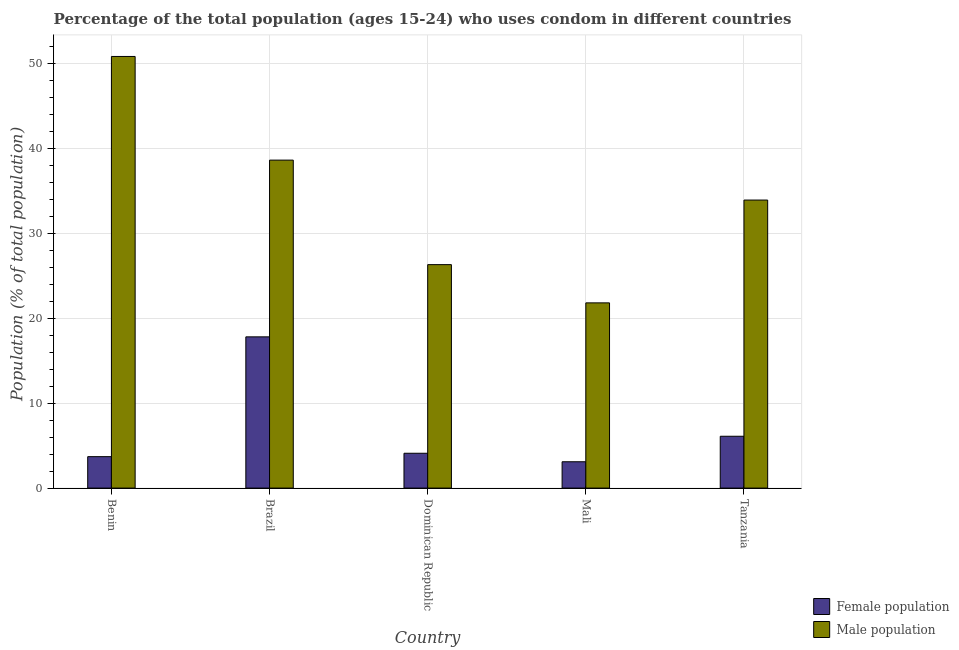How many groups of bars are there?
Make the answer very short. 5. Are the number of bars per tick equal to the number of legend labels?
Ensure brevity in your answer.  Yes. How many bars are there on the 2nd tick from the left?
Provide a short and direct response. 2. How many bars are there on the 3rd tick from the right?
Offer a very short reply. 2. What is the label of the 2nd group of bars from the left?
Provide a short and direct response. Brazil. Across all countries, what is the minimum female population?
Make the answer very short. 3.1. In which country was the female population maximum?
Your response must be concise. Brazil. In which country was the female population minimum?
Offer a terse response. Mali. What is the total male population in the graph?
Give a very brief answer. 171.4. What is the difference between the male population in Benin and that in Brazil?
Make the answer very short. 12.2. What is the difference between the male population in Brazil and the female population in Dominican Republic?
Your response must be concise. 34.5. What is the average male population per country?
Your answer should be very brief. 34.28. What is the difference between the male population and female population in Dominican Republic?
Make the answer very short. 22.2. In how many countries, is the male population greater than 20 %?
Provide a succinct answer. 5. What is the ratio of the female population in Benin to that in Mali?
Offer a very short reply. 1.19. Is the male population in Mali less than that in Tanzania?
Provide a short and direct response. Yes. Is the difference between the male population in Mali and Tanzania greater than the difference between the female population in Mali and Tanzania?
Offer a very short reply. No. What is the difference between the highest and the second highest male population?
Offer a very short reply. 12.2. What is the difference between the highest and the lowest female population?
Your answer should be very brief. 14.7. Is the sum of the female population in Mali and Tanzania greater than the maximum male population across all countries?
Provide a short and direct response. No. What does the 1st bar from the left in Brazil represents?
Offer a very short reply. Female population. What does the 1st bar from the right in Tanzania represents?
Offer a terse response. Male population. Are all the bars in the graph horizontal?
Offer a terse response. No. How many countries are there in the graph?
Offer a terse response. 5. What is the difference between two consecutive major ticks on the Y-axis?
Make the answer very short. 10. Are the values on the major ticks of Y-axis written in scientific E-notation?
Offer a terse response. No. Does the graph contain any zero values?
Ensure brevity in your answer.  No. Does the graph contain grids?
Give a very brief answer. Yes. How many legend labels are there?
Keep it short and to the point. 2. What is the title of the graph?
Your answer should be very brief. Percentage of the total population (ages 15-24) who uses condom in different countries. Does "Females" appear as one of the legend labels in the graph?
Ensure brevity in your answer.  No. What is the label or title of the Y-axis?
Make the answer very short. Population (% of total population) . What is the Population (% of total population)  of Male population in Benin?
Make the answer very short. 50.8. What is the Population (% of total population)  of Female population in Brazil?
Give a very brief answer. 17.8. What is the Population (% of total population)  of Male population in Brazil?
Provide a short and direct response. 38.6. What is the Population (% of total population)  of Female population in Dominican Republic?
Offer a very short reply. 4.1. What is the Population (% of total population)  in Male population in Dominican Republic?
Provide a succinct answer. 26.3. What is the Population (% of total population)  in Female population in Mali?
Your response must be concise. 3.1. What is the Population (% of total population)  in Male population in Mali?
Offer a terse response. 21.8. What is the Population (% of total population)  in Female population in Tanzania?
Your answer should be very brief. 6.1. What is the Population (% of total population)  in Male population in Tanzania?
Keep it short and to the point. 33.9. Across all countries, what is the maximum Population (% of total population)  in Female population?
Your response must be concise. 17.8. Across all countries, what is the maximum Population (% of total population)  of Male population?
Offer a very short reply. 50.8. Across all countries, what is the minimum Population (% of total population)  of Male population?
Ensure brevity in your answer.  21.8. What is the total Population (% of total population)  in Female population in the graph?
Offer a very short reply. 34.8. What is the total Population (% of total population)  in Male population in the graph?
Offer a very short reply. 171.4. What is the difference between the Population (% of total population)  in Female population in Benin and that in Brazil?
Keep it short and to the point. -14.1. What is the difference between the Population (% of total population)  of Female population in Benin and that in Dominican Republic?
Keep it short and to the point. -0.4. What is the difference between the Population (% of total population)  of Male population in Benin and that in Dominican Republic?
Ensure brevity in your answer.  24.5. What is the difference between the Population (% of total population)  of Female population in Benin and that in Mali?
Offer a very short reply. 0.6. What is the difference between the Population (% of total population)  in Male population in Benin and that in Mali?
Make the answer very short. 29. What is the difference between the Population (% of total population)  in Male population in Benin and that in Tanzania?
Offer a very short reply. 16.9. What is the difference between the Population (% of total population)  in Male population in Brazil and that in Dominican Republic?
Your answer should be very brief. 12.3. What is the difference between the Population (% of total population)  in Female population in Brazil and that in Tanzania?
Keep it short and to the point. 11.7. What is the difference between the Population (% of total population)  of Male population in Dominican Republic and that in Tanzania?
Provide a short and direct response. -7.6. What is the difference between the Population (% of total population)  in Male population in Mali and that in Tanzania?
Your answer should be very brief. -12.1. What is the difference between the Population (% of total population)  in Female population in Benin and the Population (% of total population)  in Male population in Brazil?
Offer a terse response. -34.9. What is the difference between the Population (% of total population)  of Female population in Benin and the Population (% of total population)  of Male population in Dominican Republic?
Provide a succinct answer. -22.6. What is the difference between the Population (% of total population)  in Female population in Benin and the Population (% of total population)  in Male population in Mali?
Your response must be concise. -18.1. What is the difference between the Population (% of total population)  in Female population in Benin and the Population (% of total population)  in Male population in Tanzania?
Your answer should be very brief. -30.2. What is the difference between the Population (% of total population)  of Female population in Brazil and the Population (% of total population)  of Male population in Dominican Republic?
Make the answer very short. -8.5. What is the difference between the Population (% of total population)  of Female population in Brazil and the Population (% of total population)  of Male population in Mali?
Offer a terse response. -4. What is the difference between the Population (% of total population)  in Female population in Brazil and the Population (% of total population)  in Male population in Tanzania?
Keep it short and to the point. -16.1. What is the difference between the Population (% of total population)  in Female population in Dominican Republic and the Population (% of total population)  in Male population in Mali?
Provide a succinct answer. -17.7. What is the difference between the Population (% of total population)  of Female population in Dominican Republic and the Population (% of total population)  of Male population in Tanzania?
Your answer should be compact. -29.8. What is the difference between the Population (% of total population)  of Female population in Mali and the Population (% of total population)  of Male population in Tanzania?
Make the answer very short. -30.8. What is the average Population (% of total population)  of Female population per country?
Provide a short and direct response. 6.96. What is the average Population (% of total population)  of Male population per country?
Provide a short and direct response. 34.28. What is the difference between the Population (% of total population)  in Female population and Population (% of total population)  in Male population in Benin?
Provide a succinct answer. -47.1. What is the difference between the Population (% of total population)  in Female population and Population (% of total population)  in Male population in Brazil?
Your answer should be very brief. -20.8. What is the difference between the Population (% of total population)  of Female population and Population (% of total population)  of Male population in Dominican Republic?
Give a very brief answer. -22.2. What is the difference between the Population (% of total population)  in Female population and Population (% of total population)  in Male population in Mali?
Make the answer very short. -18.7. What is the difference between the Population (% of total population)  of Female population and Population (% of total population)  of Male population in Tanzania?
Give a very brief answer. -27.8. What is the ratio of the Population (% of total population)  of Female population in Benin to that in Brazil?
Provide a short and direct response. 0.21. What is the ratio of the Population (% of total population)  in Male population in Benin to that in Brazil?
Offer a very short reply. 1.32. What is the ratio of the Population (% of total population)  in Female population in Benin to that in Dominican Republic?
Keep it short and to the point. 0.9. What is the ratio of the Population (% of total population)  in Male population in Benin to that in Dominican Republic?
Your answer should be compact. 1.93. What is the ratio of the Population (% of total population)  in Female population in Benin to that in Mali?
Your answer should be compact. 1.19. What is the ratio of the Population (% of total population)  of Male population in Benin to that in Mali?
Ensure brevity in your answer.  2.33. What is the ratio of the Population (% of total population)  in Female population in Benin to that in Tanzania?
Give a very brief answer. 0.61. What is the ratio of the Population (% of total population)  of Male population in Benin to that in Tanzania?
Offer a terse response. 1.5. What is the ratio of the Population (% of total population)  of Female population in Brazil to that in Dominican Republic?
Your answer should be very brief. 4.34. What is the ratio of the Population (% of total population)  of Male population in Brazil to that in Dominican Republic?
Provide a succinct answer. 1.47. What is the ratio of the Population (% of total population)  in Female population in Brazil to that in Mali?
Your response must be concise. 5.74. What is the ratio of the Population (% of total population)  in Male population in Brazil to that in Mali?
Keep it short and to the point. 1.77. What is the ratio of the Population (% of total population)  of Female population in Brazil to that in Tanzania?
Offer a very short reply. 2.92. What is the ratio of the Population (% of total population)  of Male population in Brazil to that in Tanzania?
Your answer should be very brief. 1.14. What is the ratio of the Population (% of total population)  in Female population in Dominican Republic to that in Mali?
Make the answer very short. 1.32. What is the ratio of the Population (% of total population)  in Male population in Dominican Republic to that in Mali?
Provide a succinct answer. 1.21. What is the ratio of the Population (% of total population)  in Female population in Dominican Republic to that in Tanzania?
Keep it short and to the point. 0.67. What is the ratio of the Population (% of total population)  in Male population in Dominican Republic to that in Tanzania?
Provide a succinct answer. 0.78. What is the ratio of the Population (% of total population)  in Female population in Mali to that in Tanzania?
Your answer should be very brief. 0.51. What is the ratio of the Population (% of total population)  of Male population in Mali to that in Tanzania?
Provide a succinct answer. 0.64. What is the difference between the highest and the second highest Population (% of total population)  in Male population?
Ensure brevity in your answer.  12.2. What is the difference between the highest and the lowest Population (% of total population)  of Male population?
Offer a very short reply. 29. 